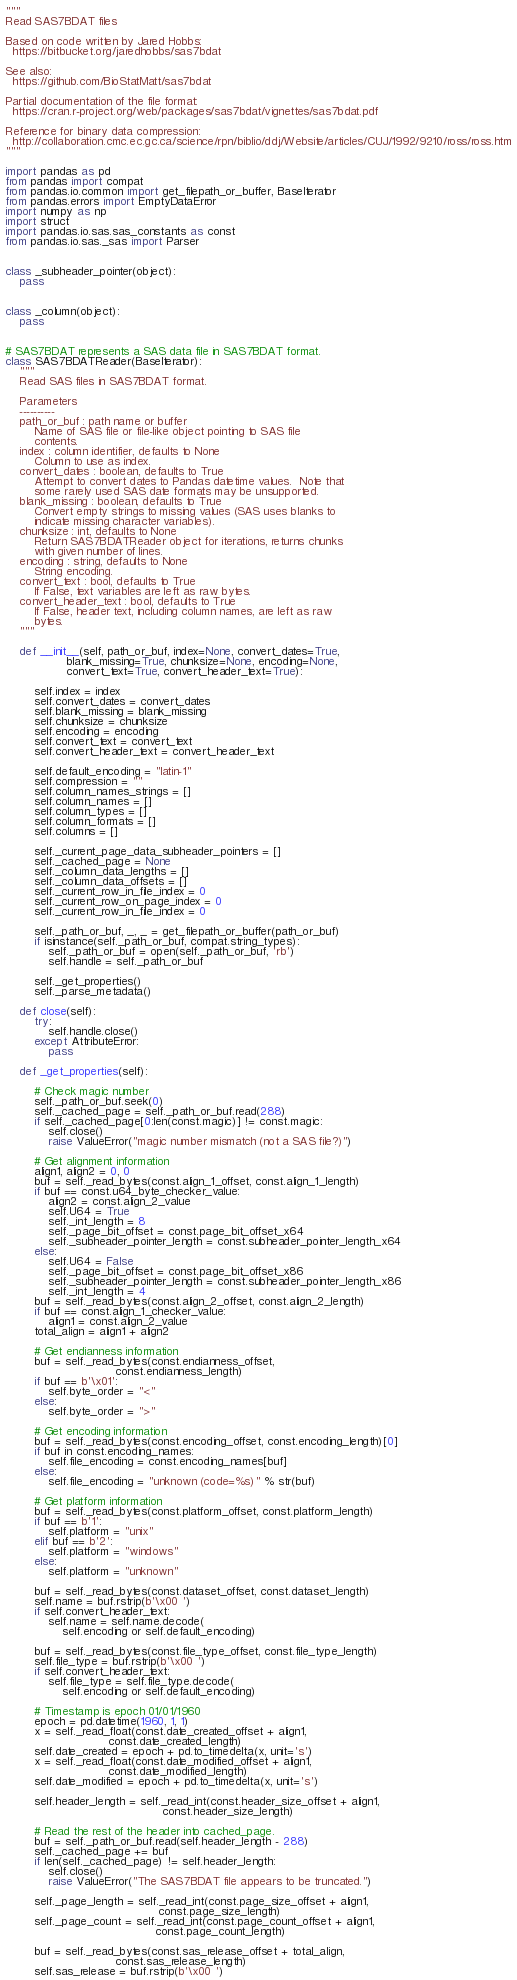<code> <loc_0><loc_0><loc_500><loc_500><_Python_>"""
Read SAS7BDAT files

Based on code written by Jared Hobbs:
  https://bitbucket.org/jaredhobbs/sas7bdat

See also:
  https://github.com/BioStatMatt/sas7bdat

Partial documentation of the file format:
  https://cran.r-project.org/web/packages/sas7bdat/vignettes/sas7bdat.pdf

Reference for binary data compression:
  http://collaboration.cmc.ec.gc.ca/science/rpn/biblio/ddj/Website/articles/CUJ/1992/9210/ross/ross.htm
"""

import pandas as pd
from pandas import compat
from pandas.io.common import get_filepath_or_buffer, BaseIterator
from pandas.errors import EmptyDataError
import numpy as np
import struct
import pandas.io.sas.sas_constants as const
from pandas.io.sas._sas import Parser


class _subheader_pointer(object):
    pass


class _column(object):
    pass


# SAS7BDAT represents a SAS data file in SAS7BDAT format.
class SAS7BDATReader(BaseIterator):
    """
    Read SAS files in SAS7BDAT format.

    Parameters
    ----------
    path_or_buf : path name or buffer
        Name of SAS file or file-like object pointing to SAS file
        contents.
    index : column identifier, defaults to None
        Column to use as index.
    convert_dates : boolean, defaults to True
        Attempt to convert dates to Pandas datetime values.  Note that
        some rarely used SAS date formats may be unsupported.
    blank_missing : boolean, defaults to True
        Convert empty strings to missing values (SAS uses blanks to
        indicate missing character variables).
    chunksize : int, defaults to None
        Return SAS7BDATReader object for iterations, returns chunks
        with given number of lines.
    encoding : string, defaults to None
        String encoding.
    convert_text : bool, defaults to True
        If False, text variables are left as raw bytes.
    convert_header_text : bool, defaults to True
        If False, header text, including column names, are left as raw
        bytes.
    """

    def __init__(self, path_or_buf, index=None, convert_dates=True,
                 blank_missing=True, chunksize=None, encoding=None,
                 convert_text=True, convert_header_text=True):

        self.index = index
        self.convert_dates = convert_dates
        self.blank_missing = blank_missing
        self.chunksize = chunksize
        self.encoding = encoding
        self.convert_text = convert_text
        self.convert_header_text = convert_header_text

        self.default_encoding = "latin-1"
        self.compression = ""
        self.column_names_strings = []
        self.column_names = []
        self.column_types = []
        self.column_formats = []
        self.columns = []

        self._current_page_data_subheader_pointers = []
        self._cached_page = None
        self._column_data_lengths = []
        self._column_data_offsets = []
        self._current_row_in_file_index = 0
        self._current_row_on_page_index = 0
        self._current_row_in_file_index = 0

        self._path_or_buf, _, _ = get_filepath_or_buffer(path_or_buf)
        if isinstance(self._path_or_buf, compat.string_types):
            self._path_or_buf = open(self._path_or_buf, 'rb')
            self.handle = self._path_or_buf

        self._get_properties()
        self._parse_metadata()

    def close(self):
        try:
            self.handle.close()
        except AttributeError:
            pass

    def _get_properties(self):

        # Check magic number
        self._path_or_buf.seek(0)
        self._cached_page = self._path_or_buf.read(288)
        if self._cached_page[0:len(const.magic)] != const.magic:
            self.close()
            raise ValueError("magic number mismatch (not a SAS file?)")

        # Get alignment information
        align1, align2 = 0, 0
        buf = self._read_bytes(const.align_1_offset, const.align_1_length)
        if buf == const.u64_byte_checker_value:
            align2 = const.align_2_value
            self.U64 = True
            self._int_length = 8
            self._page_bit_offset = const.page_bit_offset_x64
            self._subheader_pointer_length = const.subheader_pointer_length_x64
        else:
            self.U64 = False
            self._page_bit_offset = const.page_bit_offset_x86
            self._subheader_pointer_length = const.subheader_pointer_length_x86
            self._int_length = 4
        buf = self._read_bytes(const.align_2_offset, const.align_2_length)
        if buf == const.align_1_checker_value:
            align1 = const.align_2_value
        total_align = align1 + align2

        # Get endianness information
        buf = self._read_bytes(const.endianness_offset,
                               const.endianness_length)
        if buf == b'\x01':
            self.byte_order = "<"
        else:
            self.byte_order = ">"

        # Get encoding information
        buf = self._read_bytes(const.encoding_offset, const.encoding_length)[0]
        if buf in const.encoding_names:
            self.file_encoding = const.encoding_names[buf]
        else:
            self.file_encoding = "unknown (code=%s)" % str(buf)

        # Get platform information
        buf = self._read_bytes(const.platform_offset, const.platform_length)
        if buf == b'1':
            self.platform = "unix"
        elif buf == b'2':
            self.platform = "windows"
        else:
            self.platform = "unknown"

        buf = self._read_bytes(const.dataset_offset, const.dataset_length)
        self.name = buf.rstrip(b'\x00 ')
        if self.convert_header_text:
            self.name = self.name.decode(
                self.encoding or self.default_encoding)

        buf = self._read_bytes(const.file_type_offset, const.file_type_length)
        self.file_type = buf.rstrip(b'\x00 ')
        if self.convert_header_text:
            self.file_type = self.file_type.decode(
                self.encoding or self.default_encoding)

        # Timestamp is epoch 01/01/1960
        epoch = pd.datetime(1960, 1, 1)
        x = self._read_float(const.date_created_offset + align1,
                             const.date_created_length)
        self.date_created = epoch + pd.to_timedelta(x, unit='s')
        x = self._read_float(const.date_modified_offset + align1,
                             const.date_modified_length)
        self.date_modified = epoch + pd.to_timedelta(x, unit='s')

        self.header_length = self._read_int(const.header_size_offset + align1,
                                            const.header_size_length)

        # Read the rest of the header into cached_page.
        buf = self._path_or_buf.read(self.header_length - 288)
        self._cached_page += buf
        if len(self._cached_page) != self.header_length:
            self.close()
            raise ValueError("The SAS7BDAT file appears to be truncated.")

        self._page_length = self._read_int(const.page_size_offset + align1,
                                           const.page_size_length)
        self._page_count = self._read_int(const.page_count_offset + align1,
                                          const.page_count_length)

        buf = self._read_bytes(const.sas_release_offset + total_align,
                               const.sas_release_length)
        self.sas_release = buf.rstrip(b'\x00 ')</code> 